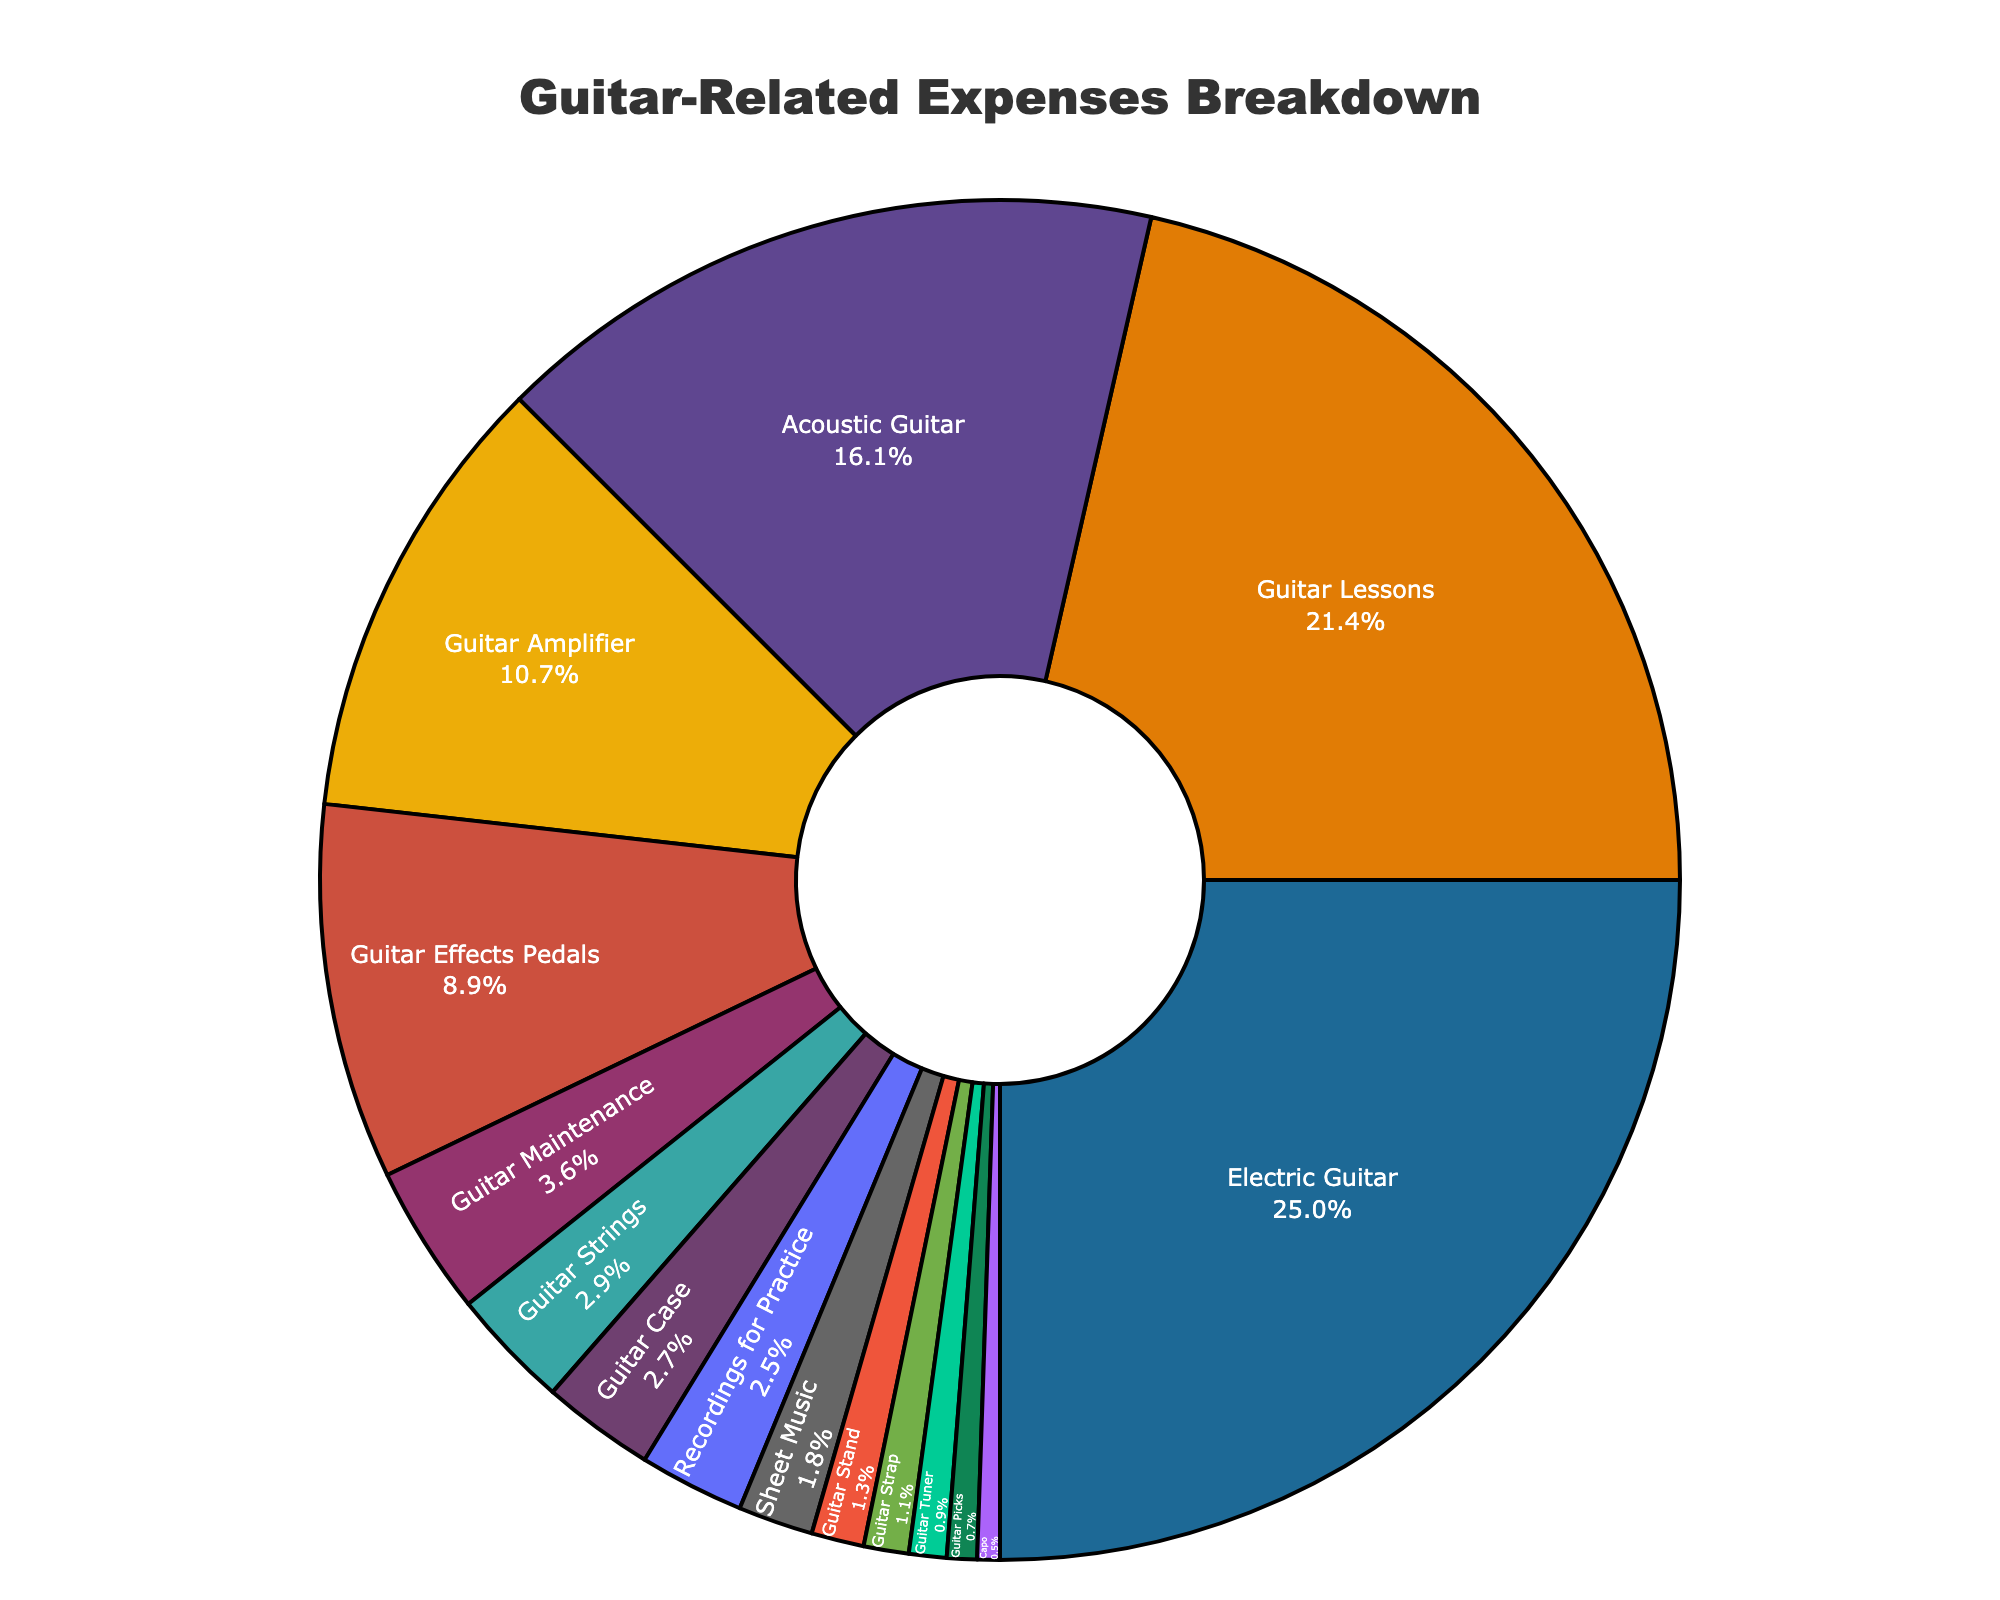what is the title of the chart? The title of the chart is displayed at the top center of the figure.
Answer: Guitar-Related Expenses Breakdown How much was spent on the Electric Guitar compared to the Acoustic Guitar? The chart shows two categories representing guitars, Electric Guitar and Acoustic Guitar, with the respective expenses displayed in percentages. By comparing the two slices, we can identify that Electric Guitar expenses are higher.
Answer: Electric Guitar expense is $700, whereas Acoustic Guitar expense is $450. Electric Guitar is $250 more Which category has the third highest expense? The pie chart presents different expense categories with their respective percentages. By examining the sizes of the slices, we can determine that Guitar Lessons and Electric Guitar are the highest, and then Guitar Amplifier has the third highest expense.
Answer: Guitar Amplifier What percentage of the expenses does Guitar Maintenance represent? To find the percentage for Guitar Maintenance, we examine the slice labeled "Guitar Maintenance" in the pie chart.
Answer: 5.3% If you combine the expenses for Guitar Picks, Guitar Strap, and Guitar Stand, what is the total expenditure? From the chart, sum the expenses for Guitar Picks ($20), Guitar Strap ($30), and Guitar Stand ($35). Adding these values together results in $85.
Answer: $85 What is the sum of the expenses for Sheet Music and Recordings for Practice? To find the combined expense for Sheet Music ($50) and Recordings for Practice ($70), add the two amounts together: $50 + $70 = $120.
Answer: $120 Which expense category has the smallest slice in the chart? The pie chart segment with the smallest size corresponds to the category with the least expense. In this chart, it is labeled "Capo."
Answer: Capo How does the expense on Guitar Effects Pedals compare to Guitar Lessons? By looking at the pie chart, observe that Guitar Lessons take up a larger slice than Guitar Effects Pedals. Guitar Lessons ($600) are more costly than Guitar Effects Pedals ($250).
Answer: Guitar Lessons are more expensive Is the expense for Guitar Cases higher or lower than for Guitar Tuners? By comparing the slices in the chart, we note that Guitar Case expenses are higher compared to Guitar Tuner expenses. Guitar Case expense is $75, while Guitar Tuner expense is $25.
Answer: Higher for Guitar Cases What is the total expenditure on items exceeding $100? Sum the expenses of all categories that have a value higher than $100: Electric Guitar ($700), Guitar Lessons ($600), Acoustic Guitar ($450), Guitar Amplifier ($300), Guitar Effects Pedals ($250), and Guitar Maintenance ($100). Their combined total is $2400.
Answer: $2400 